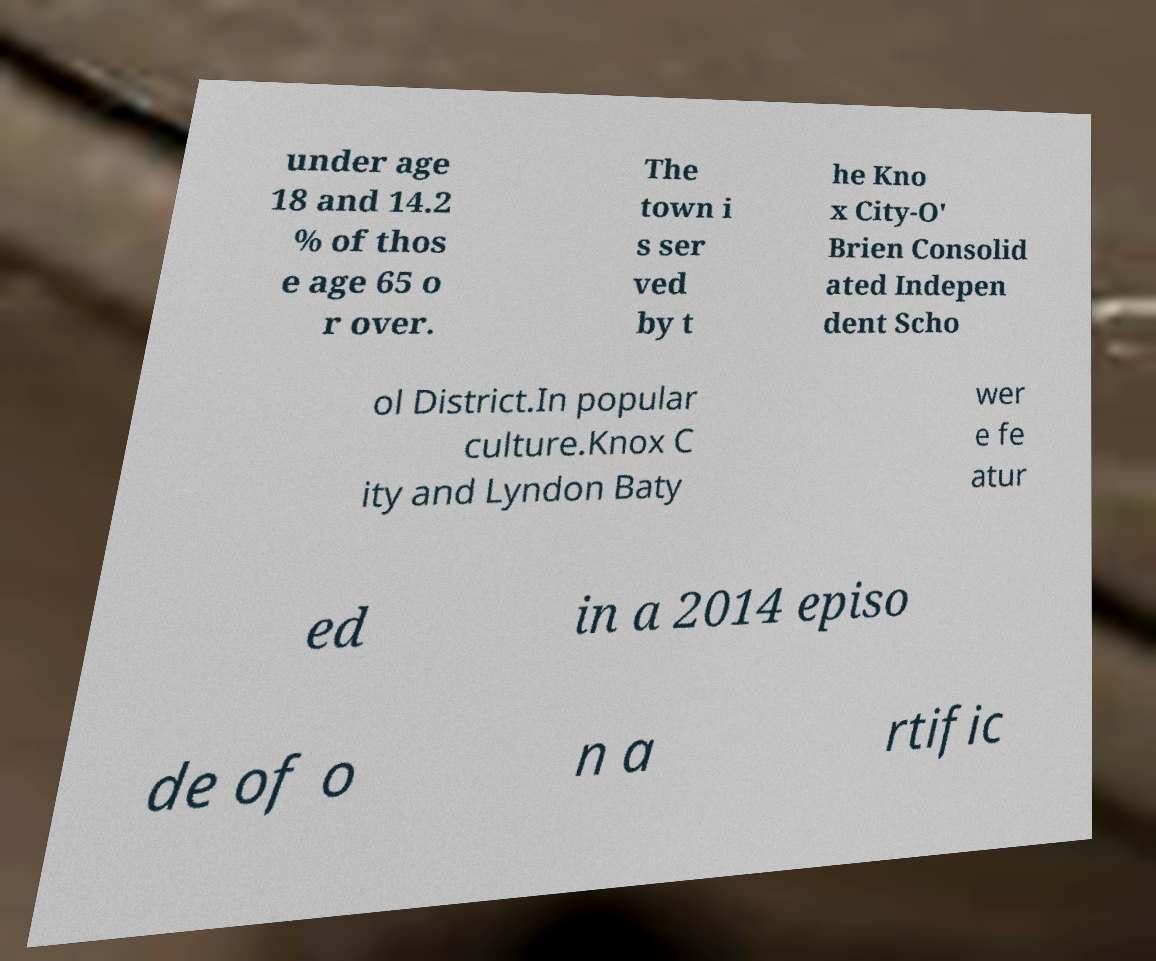Could you extract and type out the text from this image? under age 18 and 14.2 % of thos e age 65 o r over. The town i s ser ved by t he Kno x City-O' Brien Consolid ated Indepen dent Scho ol District.In popular culture.Knox C ity and Lyndon Baty wer e fe atur ed in a 2014 episo de of o n a rtific 